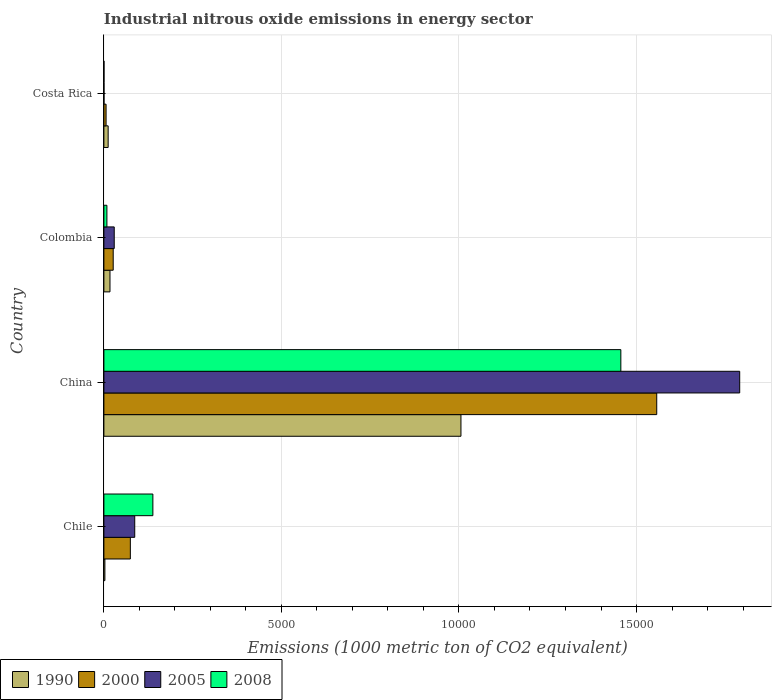Are the number of bars on each tick of the Y-axis equal?
Your answer should be compact. Yes. How many bars are there on the 1st tick from the top?
Give a very brief answer. 4. What is the label of the 2nd group of bars from the top?
Offer a very short reply. Colombia. Across all countries, what is the maximum amount of industrial nitrous oxide emitted in 2000?
Provide a succinct answer. 1.56e+04. Across all countries, what is the minimum amount of industrial nitrous oxide emitted in 1990?
Offer a terse response. 27.9. In which country was the amount of industrial nitrous oxide emitted in 2000 maximum?
Give a very brief answer. China. What is the total amount of industrial nitrous oxide emitted in 2008 in the graph?
Offer a terse response. 1.60e+04. What is the difference between the amount of industrial nitrous oxide emitted in 2000 in China and that in Colombia?
Your answer should be compact. 1.53e+04. What is the difference between the amount of industrial nitrous oxide emitted in 1990 in Costa Rica and the amount of industrial nitrous oxide emitted in 2008 in China?
Make the answer very short. -1.44e+04. What is the average amount of industrial nitrous oxide emitted in 2008 per country?
Offer a terse response. 4006.6. What is the difference between the amount of industrial nitrous oxide emitted in 2005 and amount of industrial nitrous oxide emitted in 1990 in Costa Rica?
Your answer should be compact. -116.9. In how many countries, is the amount of industrial nitrous oxide emitted in 2005 greater than 3000 1000 metric ton?
Give a very brief answer. 1. What is the ratio of the amount of industrial nitrous oxide emitted in 2008 in China to that in Costa Rica?
Your response must be concise. 4696.42. What is the difference between the highest and the second highest amount of industrial nitrous oxide emitted in 2000?
Provide a succinct answer. 1.48e+04. What is the difference between the highest and the lowest amount of industrial nitrous oxide emitted in 2008?
Keep it short and to the point. 1.46e+04. In how many countries, is the amount of industrial nitrous oxide emitted in 1990 greater than the average amount of industrial nitrous oxide emitted in 1990 taken over all countries?
Keep it short and to the point. 1. What does the 3rd bar from the top in Colombia represents?
Your answer should be compact. 2000. What does the 4th bar from the bottom in Costa Rica represents?
Your answer should be very brief. 2008. How many bars are there?
Your answer should be very brief. 16. How many countries are there in the graph?
Your response must be concise. 4. Does the graph contain any zero values?
Provide a succinct answer. No. Does the graph contain grids?
Provide a short and direct response. Yes. How many legend labels are there?
Give a very brief answer. 4. How are the legend labels stacked?
Provide a short and direct response. Horizontal. What is the title of the graph?
Offer a very short reply. Industrial nitrous oxide emissions in energy sector. What is the label or title of the X-axis?
Make the answer very short. Emissions (1000 metric ton of CO2 equivalent). What is the label or title of the Y-axis?
Your response must be concise. Country. What is the Emissions (1000 metric ton of CO2 equivalent) of 1990 in Chile?
Your answer should be compact. 27.9. What is the Emissions (1000 metric ton of CO2 equivalent) in 2000 in Chile?
Your response must be concise. 744.9. What is the Emissions (1000 metric ton of CO2 equivalent) of 2005 in Chile?
Ensure brevity in your answer.  868.8. What is the Emissions (1000 metric ton of CO2 equivalent) in 2008 in Chile?
Your answer should be compact. 1379.7. What is the Emissions (1000 metric ton of CO2 equivalent) in 1990 in China?
Ensure brevity in your answer.  1.01e+04. What is the Emissions (1000 metric ton of CO2 equivalent) in 2000 in China?
Offer a very short reply. 1.56e+04. What is the Emissions (1000 metric ton of CO2 equivalent) of 2005 in China?
Your answer should be very brief. 1.79e+04. What is the Emissions (1000 metric ton of CO2 equivalent) in 2008 in China?
Your answer should be compact. 1.46e+04. What is the Emissions (1000 metric ton of CO2 equivalent) of 1990 in Colombia?
Offer a terse response. 171.6. What is the Emissions (1000 metric ton of CO2 equivalent) of 2000 in Colombia?
Keep it short and to the point. 262.3. What is the Emissions (1000 metric ton of CO2 equivalent) in 2005 in Colombia?
Provide a succinct answer. 291.3. What is the Emissions (1000 metric ton of CO2 equivalent) of 2008 in Colombia?
Your answer should be very brief. 84.7. What is the Emissions (1000 metric ton of CO2 equivalent) in 1990 in Costa Rica?
Offer a terse response. 120. What is the Emissions (1000 metric ton of CO2 equivalent) in 2000 in Costa Rica?
Provide a succinct answer. 61.4. What is the Emissions (1000 metric ton of CO2 equivalent) of 2005 in Costa Rica?
Offer a terse response. 3.1. Across all countries, what is the maximum Emissions (1000 metric ton of CO2 equivalent) in 1990?
Ensure brevity in your answer.  1.01e+04. Across all countries, what is the maximum Emissions (1000 metric ton of CO2 equivalent) in 2000?
Your response must be concise. 1.56e+04. Across all countries, what is the maximum Emissions (1000 metric ton of CO2 equivalent) in 2005?
Make the answer very short. 1.79e+04. Across all countries, what is the maximum Emissions (1000 metric ton of CO2 equivalent) in 2008?
Provide a succinct answer. 1.46e+04. Across all countries, what is the minimum Emissions (1000 metric ton of CO2 equivalent) of 1990?
Your response must be concise. 27.9. Across all countries, what is the minimum Emissions (1000 metric ton of CO2 equivalent) in 2000?
Provide a succinct answer. 61.4. Across all countries, what is the minimum Emissions (1000 metric ton of CO2 equivalent) in 2005?
Provide a succinct answer. 3.1. Across all countries, what is the minimum Emissions (1000 metric ton of CO2 equivalent) in 2008?
Provide a succinct answer. 3.1. What is the total Emissions (1000 metric ton of CO2 equivalent) of 1990 in the graph?
Ensure brevity in your answer.  1.04e+04. What is the total Emissions (1000 metric ton of CO2 equivalent) in 2000 in the graph?
Offer a terse response. 1.66e+04. What is the total Emissions (1000 metric ton of CO2 equivalent) in 2005 in the graph?
Offer a very short reply. 1.91e+04. What is the total Emissions (1000 metric ton of CO2 equivalent) of 2008 in the graph?
Your answer should be compact. 1.60e+04. What is the difference between the Emissions (1000 metric ton of CO2 equivalent) of 1990 in Chile and that in China?
Provide a short and direct response. -1.00e+04. What is the difference between the Emissions (1000 metric ton of CO2 equivalent) in 2000 in Chile and that in China?
Offer a very short reply. -1.48e+04. What is the difference between the Emissions (1000 metric ton of CO2 equivalent) of 2005 in Chile and that in China?
Give a very brief answer. -1.70e+04. What is the difference between the Emissions (1000 metric ton of CO2 equivalent) in 2008 in Chile and that in China?
Offer a terse response. -1.32e+04. What is the difference between the Emissions (1000 metric ton of CO2 equivalent) of 1990 in Chile and that in Colombia?
Keep it short and to the point. -143.7. What is the difference between the Emissions (1000 metric ton of CO2 equivalent) in 2000 in Chile and that in Colombia?
Your response must be concise. 482.6. What is the difference between the Emissions (1000 metric ton of CO2 equivalent) in 2005 in Chile and that in Colombia?
Provide a short and direct response. 577.5. What is the difference between the Emissions (1000 metric ton of CO2 equivalent) in 2008 in Chile and that in Colombia?
Your answer should be very brief. 1295. What is the difference between the Emissions (1000 metric ton of CO2 equivalent) of 1990 in Chile and that in Costa Rica?
Provide a short and direct response. -92.1. What is the difference between the Emissions (1000 metric ton of CO2 equivalent) in 2000 in Chile and that in Costa Rica?
Keep it short and to the point. 683.5. What is the difference between the Emissions (1000 metric ton of CO2 equivalent) of 2005 in Chile and that in Costa Rica?
Your answer should be very brief. 865.7. What is the difference between the Emissions (1000 metric ton of CO2 equivalent) of 2008 in Chile and that in Costa Rica?
Ensure brevity in your answer.  1376.6. What is the difference between the Emissions (1000 metric ton of CO2 equivalent) of 1990 in China and that in Colombia?
Provide a short and direct response. 9884.5. What is the difference between the Emissions (1000 metric ton of CO2 equivalent) of 2000 in China and that in Colombia?
Make the answer very short. 1.53e+04. What is the difference between the Emissions (1000 metric ton of CO2 equivalent) in 2005 in China and that in Colombia?
Your answer should be very brief. 1.76e+04. What is the difference between the Emissions (1000 metric ton of CO2 equivalent) in 2008 in China and that in Colombia?
Provide a succinct answer. 1.45e+04. What is the difference between the Emissions (1000 metric ton of CO2 equivalent) in 1990 in China and that in Costa Rica?
Provide a short and direct response. 9936.1. What is the difference between the Emissions (1000 metric ton of CO2 equivalent) in 2000 in China and that in Costa Rica?
Your response must be concise. 1.55e+04. What is the difference between the Emissions (1000 metric ton of CO2 equivalent) in 2005 in China and that in Costa Rica?
Your response must be concise. 1.79e+04. What is the difference between the Emissions (1000 metric ton of CO2 equivalent) in 2008 in China and that in Costa Rica?
Offer a terse response. 1.46e+04. What is the difference between the Emissions (1000 metric ton of CO2 equivalent) of 1990 in Colombia and that in Costa Rica?
Your answer should be compact. 51.6. What is the difference between the Emissions (1000 metric ton of CO2 equivalent) of 2000 in Colombia and that in Costa Rica?
Your answer should be very brief. 200.9. What is the difference between the Emissions (1000 metric ton of CO2 equivalent) of 2005 in Colombia and that in Costa Rica?
Offer a terse response. 288.2. What is the difference between the Emissions (1000 metric ton of CO2 equivalent) in 2008 in Colombia and that in Costa Rica?
Provide a succinct answer. 81.6. What is the difference between the Emissions (1000 metric ton of CO2 equivalent) in 1990 in Chile and the Emissions (1000 metric ton of CO2 equivalent) in 2000 in China?
Your answer should be compact. -1.55e+04. What is the difference between the Emissions (1000 metric ton of CO2 equivalent) in 1990 in Chile and the Emissions (1000 metric ton of CO2 equivalent) in 2005 in China?
Offer a very short reply. -1.79e+04. What is the difference between the Emissions (1000 metric ton of CO2 equivalent) in 1990 in Chile and the Emissions (1000 metric ton of CO2 equivalent) in 2008 in China?
Offer a terse response. -1.45e+04. What is the difference between the Emissions (1000 metric ton of CO2 equivalent) of 2000 in Chile and the Emissions (1000 metric ton of CO2 equivalent) of 2005 in China?
Provide a succinct answer. -1.72e+04. What is the difference between the Emissions (1000 metric ton of CO2 equivalent) in 2000 in Chile and the Emissions (1000 metric ton of CO2 equivalent) in 2008 in China?
Offer a terse response. -1.38e+04. What is the difference between the Emissions (1000 metric ton of CO2 equivalent) in 2005 in Chile and the Emissions (1000 metric ton of CO2 equivalent) in 2008 in China?
Keep it short and to the point. -1.37e+04. What is the difference between the Emissions (1000 metric ton of CO2 equivalent) in 1990 in Chile and the Emissions (1000 metric ton of CO2 equivalent) in 2000 in Colombia?
Ensure brevity in your answer.  -234.4. What is the difference between the Emissions (1000 metric ton of CO2 equivalent) in 1990 in Chile and the Emissions (1000 metric ton of CO2 equivalent) in 2005 in Colombia?
Provide a short and direct response. -263.4. What is the difference between the Emissions (1000 metric ton of CO2 equivalent) in 1990 in Chile and the Emissions (1000 metric ton of CO2 equivalent) in 2008 in Colombia?
Provide a succinct answer. -56.8. What is the difference between the Emissions (1000 metric ton of CO2 equivalent) in 2000 in Chile and the Emissions (1000 metric ton of CO2 equivalent) in 2005 in Colombia?
Offer a very short reply. 453.6. What is the difference between the Emissions (1000 metric ton of CO2 equivalent) of 2000 in Chile and the Emissions (1000 metric ton of CO2 equivalent) of 2008 in Colombia?
Offer a terse response. 660.2. What is the difference between the Emissions (1000 metric ton of CO2 equivalent) of 2005 in Chile and the Emissions (1000 metric ton of CO2 equivalent) of 2008 in Colombia?
Make the answer very short. 784.1. What is the difference between the Emissions (1000 metric ton of CO2 equivalent) of 1990 in Chile and the Emissions (1000 metric ton of CO2 equivalent) of 2000 in Costa Rica?
Your answer should be very brief. -33.5. What is the difference between the Emissions (1000 metric ton of CO2 equivalent) of 1990 in Chile and the Emissions (1000 metric ton of CO2 equivalent) of 2005 in Costa Rica?
Give a very brief answer. 24.8. What is the difference between the Emissions (1000 metric ton of CO2 equivalent) of 1990 in Chile and the Emissions (1000 metric ton of CO2 equivalent) of 2008 in Costa Rica?
Offer a terse response. 24.8. What is the difference between the Emissions (1000 metric ton of CO2 equivalent) in 2000 in Chile and the Emissions (1000 metric ton of CO2 equivalent) in 2005 in Costa Rica?
Keep it short and to the point. 741.8. What is the difference between the Emissions (1000 metric ton of CO2 equivalent) in 2000 in Chile and the Emissions (1000 metric ton of CO2 equivalent) in 2008 in Costa Rica?
Ensure brevity in your answer.  741.8. What is the difference between the Emissions (1000 metric ton of CO2 equivalent) of 2005 in Chile and the Emissions (1000 metric ton of CO2 equivalent) of 2008 in Costa Rica?
Provide a succinct answer. 865.7. What is the difference between the Emissions (1000 metric ton of CO2 equivalent) of 1990 in China and the Emissions (1000 metric ton of CO2 equivalent) of 2000 in Colombia?
Offer a terse response. 9793.8. What is the difference between the Emissions (1000 metric ton of CO2 equivalent) of 1990 in China and the Emissions (1000 metric ton of CO2 equivalent) of 2005 in Colombia?
Provide a succinct answer. 9764.8. What is the difference between the Emissions (1000 metric ton of CO2 equivalent) of 1990 in China and the Emissions (1000 metric ton of CO2 equivalent) of 2008 in Colombia?
Keep it short and to the point. 9971.4. What is the difference between the Emissions (1000 metric ton of CO2 equivalent) in 2000 in China and the Emissions (1000 metric ton of CO2 equivalent) in 2005 in Colombia?
Your response must be concise. 1.53e+04. What is the difference between the Emissions (1000 metric ton of CO2 equivalent) of 2000 in China and the Emissions (1000 metric ton of CO2 equivalent) of 2008 in Colombia?
Ensure brevity in your answer.  1.55e+04. What is the difference between the Emissions (1000 metric ton of CO2 equivalent) in 2005 in China and the Emissions (1000 metric ton of CO2 equivalent) in 2008 in Colombia?
Keep it short and to the point. 1.78e+04. What is the difference between the Emissions (1000 metric ton of CO2 equivalent) in 1990 in China and the Emissions (1000 metric ton of CO2 equivalent) in 2000 in Costa Rica?
Give a very brief answer. 9994.7. What is the difference between the Emissions (1000 metric ton of CO2 equivalent) in 1990 in China and the Emissions (1000 metric ton of CO2 equivalent) in 2005 in Costa Rica?
Offer a terse response. 1.01e+04. What is the difference between the Emissions (1000 metric ton of CO2 equivalent) in 1990 in China and the Emissions (1000 metric ton of CO2 equivalent) in 2008 in Costa Rica?
Offer a very short reply. 1.01e+04. What is the difference between the Emissions (1000 metric ton of CO2 equivalent) of 2000 in China and the Emissions (1000 metric ton of CO2 equivalent) of 2005 in Costa Rica?
Ensure brevity in your answer.  1.56e+04. What is the difference between the Emissions (1000 metric ton of CO2 equivalent) of 2000 in China and the Emissions (1000 metric ton of CO2 equivalent) of 2008 in Costa Rica?
Your answer should be very brief. 1.56e+04. What is the difference between the Emissions (1000 metric ton of CO2 equivalent) in 2005 in China and the Emissions (1000 metric ton of CO2 equivalent) in 2008 in Costa Rica?
Your answer should be compact. 1.79e+04. What is the difference between the Emissions (1000 metric ton of CO2 equivalent) in 1990 in Colombia and the Emissions (1000 metric ton of CO2 equivalent) in 2000 in Costa Rica?
Make the answer very short. 110.2. What is the difference between the Emissions (1000 metric ton of CO2 equivalent) in 1990 in Colombia and the Emissions (1000 metric ton of CO2 equivalent) in 2005 in Costa Rica?
Your answer should be very brief. 168.5. What is the difference between the Emissions (1000 metric ton of CO2 equivalent) in 1990 in Colombia and the Emissions (1000 metric ton of CO2 equivalent) in 2008 in Costa Rica?
Your answer should be very brief. 168.5. What is the difference between the Emissions (1000 metric ton of CO2 equivalent) of 2000 in Colombia and the Emissions (1000 metric ton of CO2 equivalent) of 2005 in Costa Rica?
Offer a terse response. 259.2. What is the difference between the Emissions (1000 metric ton of CO2 equivalent) of 2000 in Colombia and the Emissions (1000 metric ton of CO2 equivalent) of 2008 in Costa Rica?
Provide a succinct answer. 259.2. What is the difference between the Emissions (1000 metric ton of CO2 equivalent) of 2005 in Colombia and the Emissions (1000 metric ton of CO2 equivalent) of 2008 in Costa Rica?
Offer a terse response. 288.2. What is the average Emissions (1000 metric ton of CO2 equivalent) of 1990 per country?
Offer a terse response. 2593.9. What is the average Emissions (1000 metric ton of CO2 equivalent) of 2000 per country?
Offer a terse response. 4159.57. What is the average Emissions (1000 metric ton of CO2 equivalent) in 2005 per country?
Offer a terse response. 4767.4. What is the average Emissions (1000 metric ton of CO2 equivalent) in 2008 per country?
Make the answer very short. 4006.6. What is the difference between the Emissions (1000 metric ton of CO2 equivalent) of 1990 and Emissions (1000 metric ton of CO2 equivalent) of 2000 in Chile?
Make the answer very short. -717. What is the difference between the Emissions (1000 metric ton of CO2 equivalent) in 1990 and Emissions (1000 metric ton of CO2 equivalent) in 2005 in Chile?
Offer a terse response. -840.9. What is the difference between the Emissions (1000 metric ton of CO2 equivalent) of 1990 and Emissions (1000 metric ton of CO2 equivalent) of 2008 in Chile?
Give a very brief answer. -1351.8. What is the difference between the Emissions (1000 metric ton of CO2 equivalent) in 2000 and Emissions (1000 metric ton of CO2 equivalent) in 2005 in Chile?
Your answer should be compact. -123.9. What is the difference between the Emissions (1000 metric ton of CO2 equivalent) in 2000 and Emissions (1000 metric ton of CO2 equivalent) in 2008 in Chile?
Offer a very short reply. -634.8. What is the difference between the Emissions (1000 metric ton of CO2 equivalent) of 2005 and Emissions (1000 metric ton of CO2 equivalent) of 2008 in Chile?
Keep it short and to the point. -510.9. What is the difference between the Emissions (1000 metric ton of CO2 equivalent) of 1990 and Emissions (1000 metric ton of CO2 equivalent) of 2000 in China?
Provide a short and direct response. -5513.6. What is the difference between the Emissions (1000 metric ton of CO2 equivalent) of 1990 and Emissions (1000 metric ton of CO2 equivalent) of 2005 in China?
Your answer should be very brief. -7850.3. What is the difference between the Emissions (1000 metric ton of CO2 equivalent) in 1990 and Emissions (1000 metric ton of CO2 equivalent) in 2008 in China?
Your response must be concise. -4502.8. What is the difference between the Emissions (1000 metric ton of CO2 equivalent) of 2000 and Emissions (1000 metric ton of CO2 equivalent) of 2005 in China?
Offer a very short reply. -2336.7. What is the difference between the Emissions (1000 metric ton of CO2 equivalent) in 2000 and Emissions (1000 metric ton of CO2 equivalent) in 2008 in China?
Offer a very short reply. 1010.8. What is the difference between the Emissions (1000 metric ton of CO2 equivalent) in 2005 and Emissions (1000 metric ton of CO2 equivalent) in 2008 in China?
Offer a terse response. 3347.5. What is the difference between the Emissions (1000 metric ton of CO2 equivalent) in 1990 and Emissions (1000 metric ton of CO2 equivalent) in 2000 in Colombia?
Ensure brevity in your answer.  -90.7. What is the difference between the Emissions (1000 metric ton of CO2 equivalent) of 1990 and Emissions (1000 metric ton of CO2 equivalent) of 2005 in Colombia?
Your response must be concise. -119.7. What is the difference between the Emissions (1000 metric ton of CO2 equivalent) in 1990 and Emissions (1000 metric ton of CO2 equivalent) in 2008 in Colombia?
Provide a short and direct response. 86.9. What is the difference between the Emissions (1000 metric ton of CO2 equivalent) of 2000 and Emissions (1000 metric ton of CO2 equivalent) of 2005 in Colombia?
Provide a succinct answer. -29. What is the difference between the Emissions (1000 metric ton of CO2 equivalent) of 2000 and Emissions (1000 metric ton of CO2 equivalent) of 2008 in Colombia?
Provide a short and direct response. 177.6. What is the difference between the Emissions (1000 metric ton of CO2 equivalent) of 2005 and Emissions (1000 metric ton of CO2 equivalent) of 2008 in Colombia?
Provide a succinct answer. 206.6. What is the difference between the Emissions (1000 metric ton of CO2 equivalent) of 1990 and Emissions (1000 metric ton of CO2 equivalent) of 2000 in Costa Rica?
Ensure brevity in your answer.  58.6. What is the difference between the Emissions (1000 metric ton of CO2 equivalent) in 1990 and Emissions (1000 metric ton of CO2 equivalent) in 2005 in Costa Rica?
Your answer should be very brief. 116.9. What is the difference between the Emissions (1000 metric ton of CO2 equivalent) in 1990 and Emissions (1000 metric ton of CO2 equivalent) in 2008 in Costa Rica?
Offer a terse response. 116.9. What is the difference between the Emissions (1000 metric ton of CO2 equivalent) of 2000 and Emissions (1000 metric ton of CO2 equivalent) of 2005 in Costa Rica?
Offer a very short reply. 58.3. What is the difference between the Emissions (1000 metric ton of CO2 equivalent) of 2000 and Emissions (1000 metric ton of CO2 equivalent) of 2008 in Costa Rica?
Make the answer very short. 58.3. What is the ratio of the Emissions (1000 metric ton of CO2 equivalent) in 1990 in Chile to that in China?
Keep it short and to the point. 0. What is the ratio of the Emissions (1000 metric ton of CO2 equivalent) in 2000 in Chile to that in China?
Make the answer very short. 0.05. What is the ratio of the Emissions (1000 metric ton of CO2 equivalent) of 2005 in Chile to that in China?
Provide a succinct answer. 0.05. What is the ratio of the Emissions (1000 metric ton of CO2 equivalent) of 2008 in Chile to that in China?
Make the answer very short. 0.09. What is the ratio of the Emissions (1000 metric ton of CO2 equivalent) in 1990 in Chile to that in Colombia?
Give a very brief answer. 0.16. What is the ratio of the Emissions (1000 metric ton of CO2 equivalent) in 2000 in Chile to that in Colombia?
Keep it short and to the point. 2.84. What is the ratio of the Emissions (1000 metric ton of CO2 equivalent) in 2005 in Chile to that in Colombia?
Your answer should be very brief. 2.98. What is the ratio of the Emissions (1000 metric ton of CO2 equivalent) of 2008 in Chile to that in Colombia?
Provide a succinct answer. 16.29. What is the ratio of the Emissions (1000 metric ton of CO2 equivalent) of 1990 in Chile to that in Costa Rica?
Provide a short and direct response. 0.23. What is the ratio of the Emissions (1000 metric ton of CO2 equivalent) of 2000 in Chile to that in Costa Rica?
Offer a very short reply. 12.13. What is the ratio of the Emissions (1000 metric ton of CO2 equivalent) in 2005 in Chile to that in Costa Rica?
Ensure brevity in your answer.  280.26. What is the ratio of the Emissions (1000 metric ton of CO2 equivalent) of 2008 in Chile to that in Costa Rica?
Your answer should be compact. 445.06. What is the ratio of the Emissions (1000 metric ton of CO2 equivalent) of 1990 in China to that in Colombia?
Make the answer very short. 58.6. What is the ratio of the Emissions (1000 metric ton of CO2 equivalent) of 2000 in China to that in Colombia?
Ensure brevity in your answer.  59.36. What is the ratio of the Emissions (1000 metric ton of CO2 equivalent) of 2005 in China to that in Colombia?
Offer a terse response. 61.47. What is the ratio of the Emissions (1000 metric ton of CO2 equivalent) in 2008 in China to that in Colombia?
Provide a succinct answer. 171.89. What is the ratio of the Emissions (1000 metric ton of CO2 equivalent) of 1990 in China to that in Costa Rica?
Your response must be concise. 83.8. What is the ratio of the Emissions (1000 metric ton of CO2 equivalent) of 2000 in China to that in Costa Rica?
Your response must be concise. 253.58. What is the ratio of the Emissions (1000 metric ton of CO2 equivalent) in 2005 in China to that in Costa Rica?
Your answer should be very brief. 5776.26. What is the ratio of the Emissions (1000 metric ton of CO2 equivalent) of 2008 in China to that in Costa Rica?
Provide a succinct answer. 4696.42. What is the ratio of the Emissions (1000 metric ton of CO2 equivalent) in 1990 in Colombia to that in Costa Rica?
Your answer should be very brief. 1.43. What is the ratio of the Emissions (1000 metric ton of CO2 equivalent) of 2000 in Colombia to that in Costa Rica?
Your answer should be very brief. 4.27. What is the ratio of the Emissions (1000 metric ton of CO2 equivalent) in 2005 in Colombia to that in Costa Rica?
Your answer should be compact. 93.97. What is the ratio of the Emissions (1000 metric ton of CO2 equivalent) of 2008 in Colombia to that in Costa Rica?
Make the answer very short. 27.32. What is the difference between the highest and the second highest Emissions (1000 metric ton of CO2 equivalent) of 1990?
Provide a succinct answer. 9884.5. What is the difference between the highest and the second highest Emissions (1000 metric ton of CO2 equivalent) in 2000?
Your response must be concise. 1.48e+04. What is the difference between the highest and the second highest Emissions (1000 metric ton of CO2 equivalent) of 2005?
Make the answer very short. 1.70e+04. What is the difference between the highest and the second highest Emissions (1000 metric ton of CO2 equivalent) in 2008?
Your answer should be very brief. 1.32e+04. What is the difference between the highest and the lowest Emissions (1000 metric ton of CO2 equivalent) of 1990?
Give a very brief answer. 1.00e+04. What is the difference between the highest and the lowest Emissions (1000 metric ton of CO2 equivalent) of 2000?
Your response must be concise. 1.55e+04. What is the difference between the highest and the lowest Emissions (1000 metric ton of CO2 equivalent) in 2005?
Provide a short and direct response. 1.79e+04. What is the difference between the highest and the lowest Emissions (1000 metric ton of CO2 equivalent) in 2008?
Your response must be concise. 1.46e+04. 